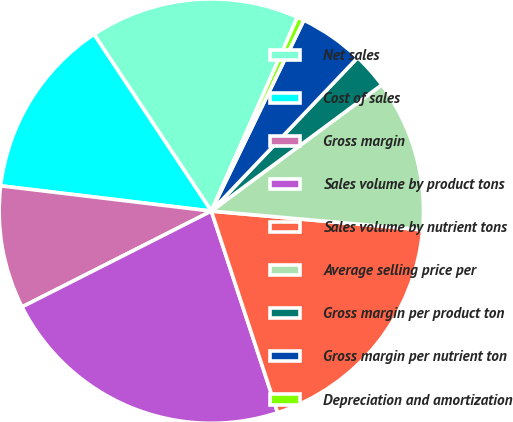Convert chart. <chart><loc_0><loc_0><loc_500><loc_500><pie_chart><fcel>Net sales<fcel>Cost of sales<fcel>Gross margin<fcel>Sales volume by product tons<fcel>Sales volume by nutrient tons<fcel>Average selling price per<fcel>Gross margin per product ton<fcel>Gross margin per nutrient ton<fcel>Depreciation and amortization<nl><fcel>15.98%<fcel>13.77%<fcel>9.36%<fcel>22.6%<fcel>18.53%<fcel>11.56%<fcel>2.73%<fcel>4.94%<fcel>0.53%<nl></chart> 